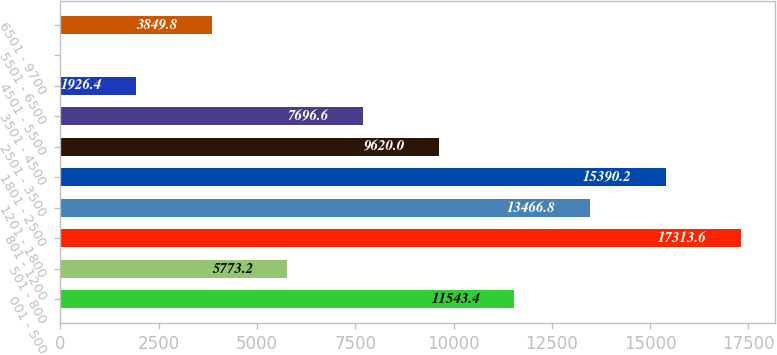Convert chart to OTSL. <chart><loc_0><loc_0><loc_500><loc_500><bar_chart><fcel>001 - 500<fcel>501 - 800<fcel>801 - 1200<fcel>1201 - 1800<fcel>1801 - 2500<fcel>2501 - 3500<fcel>3501 - 4500<fcel>4501 - 5500<fcel>5501 - 6500<fcel>6501 - 9700<nl><fcel>11543.4<fcel>5773.2<fcel>17313.6<fcel>13466.8<fcel>15390.2<fcel>9620<fcel>7696.6<fcel>1926.4<fcel>3<fcel>3849.8<nl></chart> 